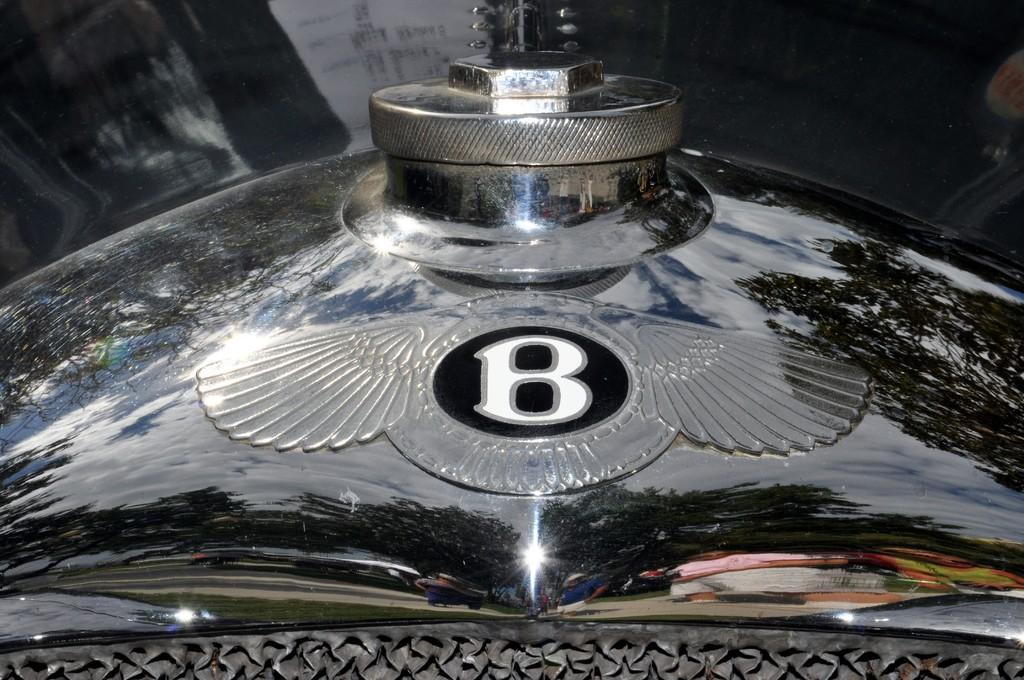What type of object is in the image? There is an iron object in the image. What color is the iron object? The iron object is black in color. Is there any lettering or symbol on the iron object? Yes, the symbol 'B' is present on the iron object. Where can the beef be found in the image? There is no beef present in the image. What type of truck is visible in the image? There is no truck present in the image. 